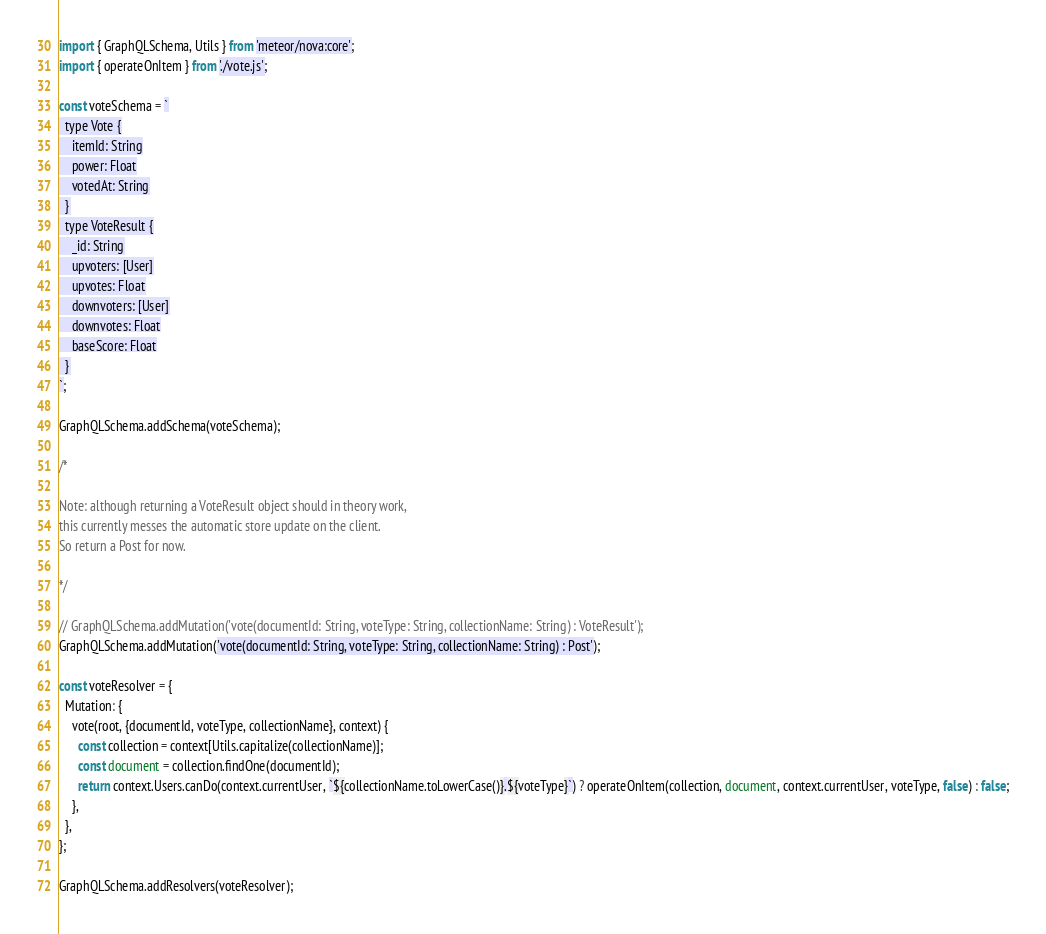Convert code to text. <code><loc_0><loc_0><loc_500><loc_500><_JavaScript_>import { GraphQLSchema, Utils } from 'meteor/nova:core';
import { operateOnItem } from './vote.js';

const voteSchema = `
  type Vote {
    itemId: String
    power: Float
    votedAt: String
  }
  type VoteResult {
    _id: String
    upvoters: [User]
    upvotes: Float
    downvoters: [User]
    downvotes: Float
    baseScore: Float
  }
`;

GraphQLSchema.addSchema(voteSchema);

/*

Note: although returning a VoteResult object should in theory work, 
this currently messes the automatic store update on the client. 
So return a Post for now. 

*/

// GraphQLSchema.addMutation('vote(documentId: String, voteType: String, collectionName: String) : VoteResult');
GraphQLSchema.addMutation('vote(documentId: String, voteType: String, collectionName: String) : Post');

const voteResolver = {
  Mutation: {
    vote(root, {documentId, voteType, collectionName}, context) {
      const collection = context[Utils.capitalize(collectionName)];
      const document = collection.findOne(documentId);
      return context.Users.canDo(context.currentUser, `${collectionName.toLowerCase()}.${voteType}`) ? operateOnItem(collection, document, context.currentUser, voteType, false) : false;
    },
  },
};

GraphQLSchema.addResolvers(voteResolver);
</code> 